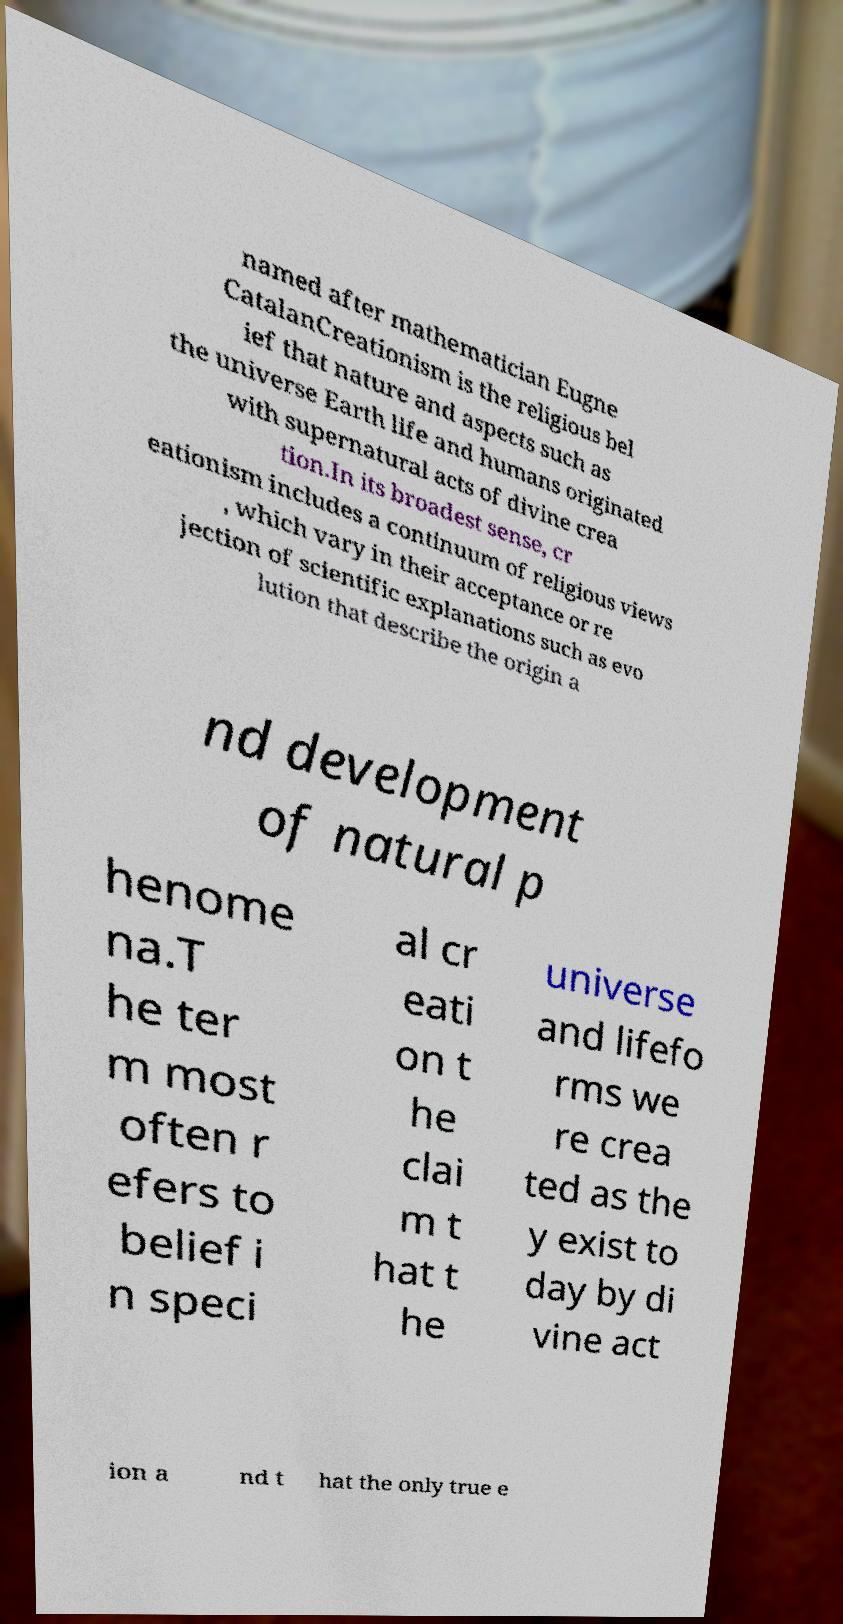Can you read and provide the text displayed in the image?This photo seems to have some interesting text. Can you extract and type it out for me? named after mathematician Eugne CatalanCreationism is the religious bel ief that nature and aspects such as the universe Earth life and humans originated with supernatural acts of divine crea tion.In its broadest sense, cr eationism includes a continuum of religious views , which vary in their acceptance or re jection of scientific explanations such as evo lution that describe the origin a nd development of natural p henome na.T he ter m most often r efers to belief i n speci al cr eati on t he clai m t hat t he universe and lifefo rms we re crea ted as the y exist to day by di vine act ion a nd t hat the only true e 